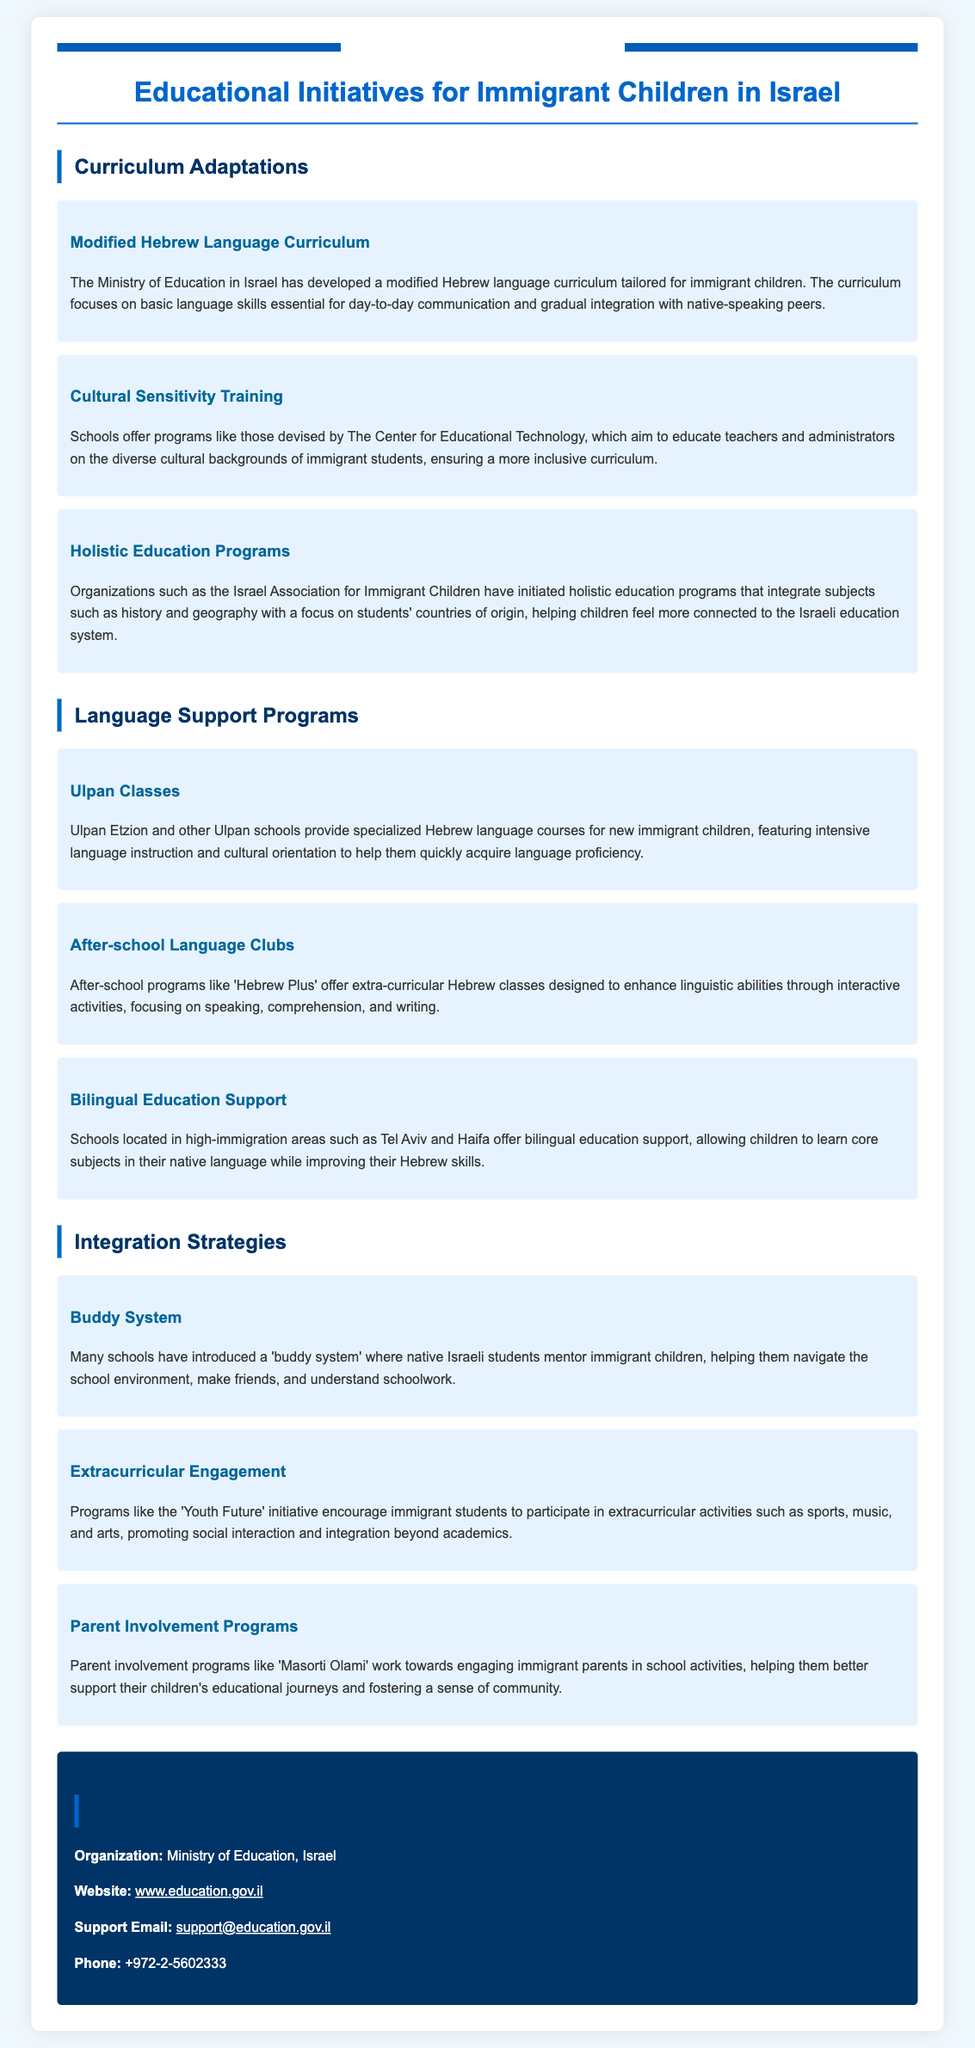What is the focus of the modified Hebrew language curriculum? The modified Hebrew language curriculum focuses on basic language skills essential for day-to-day communication and gradual integration with native-speaking peers.
Answer: Basic language skills Which organization developed cultural sensitivity training programs? The training programs for teachers and administrators on diverse cultural backgrounds of immigrant students are devised by The Center for Educational Technology.
Answer: The Center for Educational Technology What type of classes do Ulpan schools provide? Ulpan schools provide specialized Hebrew language courses featuring intensive language instruction and cultural orientation.
Answer: Hebrew language courses What is the purpose of the buddy system in schools? The buddy system helps immigrant children navigate the school environment, make friends, and understand schoolwork through mentorship from native Israeli students.
Answer: Mentorship Which initiative encourages immigrant students to participate in extracurricular activities? The initiative that encourages participation in extracurricular activities is called 'Youth Future.'
Answer: Youth Future What is the contact email for the Ministry of Education in Israel? The document provides a support email contact for the Ministry of Education, which is used for inquiries.
Answer: support@education.gov.il How does the bilingual education support affect children? Bilingual education support allows children to learn core subjects in their native language while improving their Hebrew skills.
Answer: Learn core subjects in their native language What approach do parent involvement programs like 'Masorti Olami' promote? Parent involvement programs work towards engaging immigrant parents in school activities to better support their children's educational journeys.
Answer: Engaging immigrant parents What type of education programs does the Israel Association for Immigrant Children initiate? The Israel Association for Immigrant Children initiates holistic education programs that integrate subjects with a focus on the students' countries of origin.
Answer: Holistic education programs 